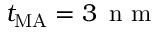<formula> <loc_0><loc_0><loc_500><loc_500>t _ { M A } = 3 \, n m</formula> 